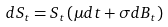<formula> <loc_0><loc_0><loc_500><loc_500>d S _ { t } = S _ { t } \left ( \mu d t + \sigma d B _ { t } \right )</formula> 